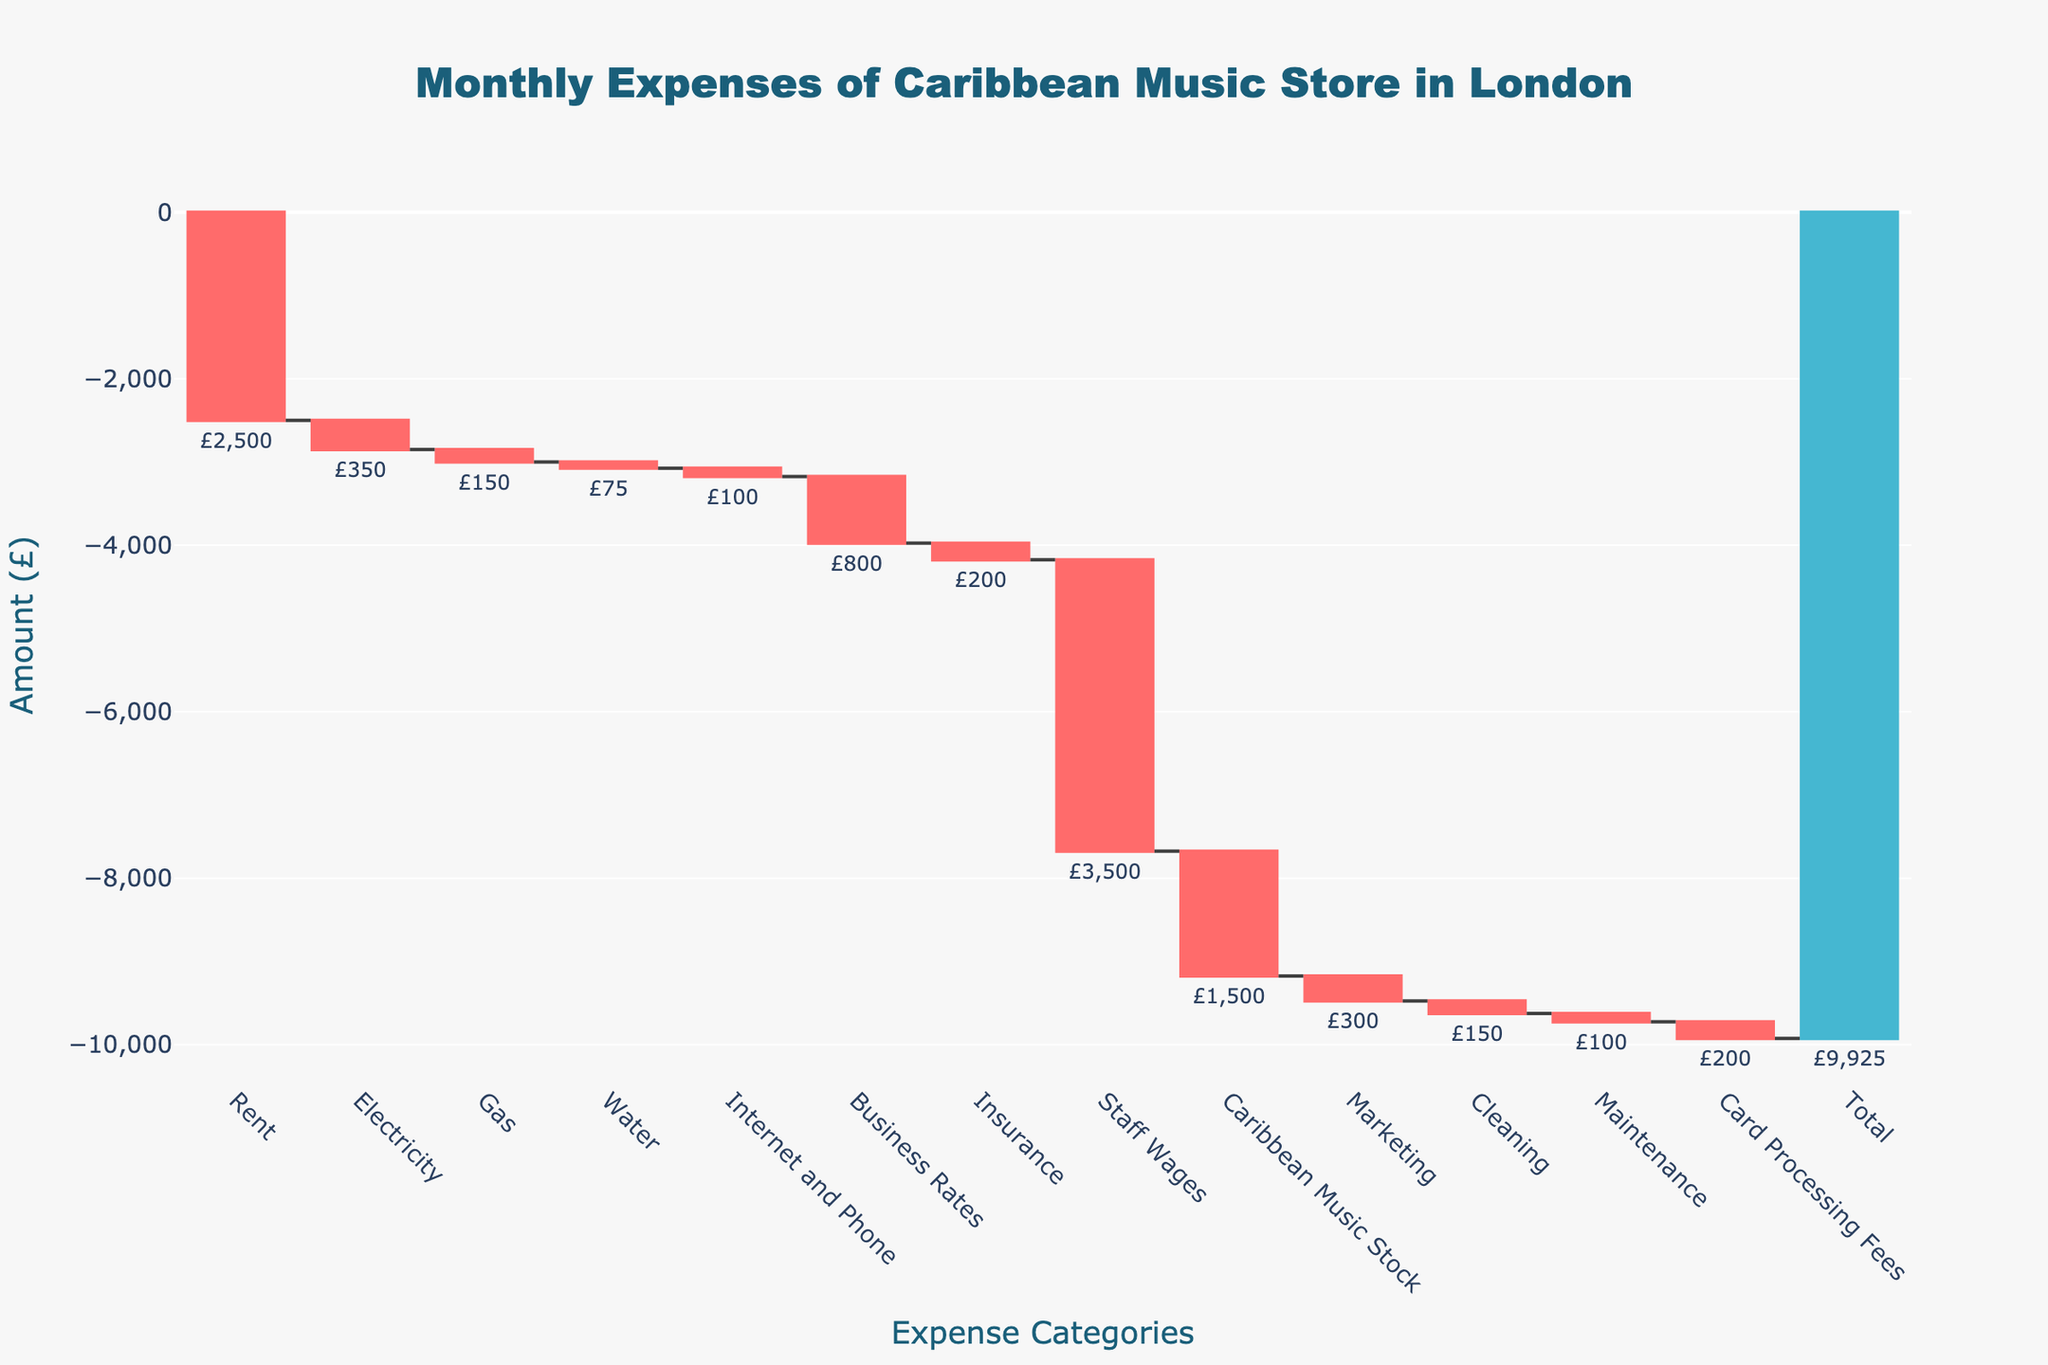What's the total monthly expenses shown in the chart? The figure shows a total expense bar at the end with a labelled amount. This includes all the cumulative expenses shown in the waterfall chart.
Answer: £9,925 What is the largest individual expense category? Looking at the individual bars in the waterfall chart, the one that drops the most is for "Staff Wages".
Answer: Staff Wages How much is spent on Rent and Utilities combined? Rent is £2,500, Electricity is £350, Gas is £150, and Water is £75. Sum these values: £2,500 + £350 + £150 + £75.
Answer: £3,075 How do Rent and Staff Wages compare? Compare the bars for Rent (£2,500) and Staff Wages (£3,500) to see which is larger. Staff Wages is larger.
Answer: Staff Wages is £1,000 higher than Rent What percentage of total expenses does Rent represent? Rent is £2,500, the total expenses are £9,925. Divide Rent by total expenses and multiply by 100 to get the percentage: (2,500 / 9,925) * 100.
Answer: ~25.2% Which category has the smallest expense? Find the shortest bar in the waterfall chart, which is "Water" at £75.
Answer: Water Is the expense for Electricity more or less than the expense for Gas? Compare the bars for Electricity (£350) and Gas (£150); Electricity is more.
Answer: Electricity is more than Gas What are the combined expenses for Insurance, Marketing, and Cleaning? Sum the amounts for Insurance (£200), Marketing (£300), and Cleaning (£150): £200 + £300 + £150.
Answer: £650 What is the difference between Internet and Phone expenses versus Card Processing Fees? Subtract the amount for Internet and Phone (£100) from Card Processing Fees (£200): £200 - £100.
Answer: £100 Given the pattern, if we add another category named "Misc Expenses" with an amount of £500, what would be the new total expense? Add £500 to the existing total of £9,925: £9,925 + £500.
Answer: £10,425 